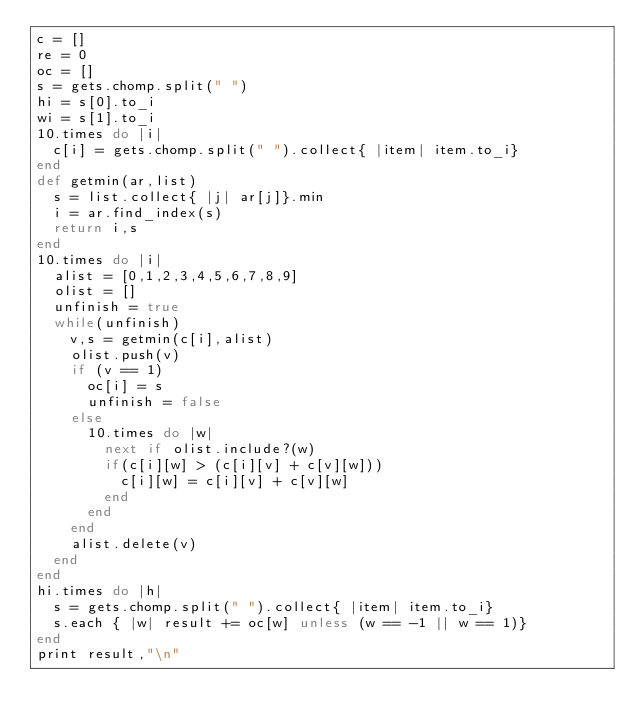Convert code to text. <code><loc_0><loc_0><loc_500><loc_500><_Ruby_>c = []
re = 0
oc = []
s = gets.chomp.split(" ")
hi = s[0].to_i
wi = s[1].to_i
10.times do |i|
  c[i] = gets.chomp.split(" ").collect{ |item| item.to_i}
end
def getmin(ar,list)
  s = list.collect{ |j| ar[j]}.min
  i = ar.find_index(s)
  return i,s
end
10.times do |i|
  alist = [0,1,2,3,4,5,6,7,8,9]
  olist = []
  unfinish = true
  while(unfinish)
    v,s = getmin(c[i],alist)
    olist.push(v)
    if (v == 1)
      oc[i] = s
      unfinish = false
    else
      10.times do |w|
        next if olist.include?(w)
        if(c[i][w] > (c[i][v] + c[v][w]))
          c[i][w] = c[i][v] + c[v][w]
        end
      end
    end
    alist.delete(v)
  end
end
hi.times do |h|
  s = gets.chomp.split(" ").collect{ |item| item.to_i}
  s.each { |w| result += oc[w] unless (w == -1 || w == 1)}
end
print result,"\n"
</code> 